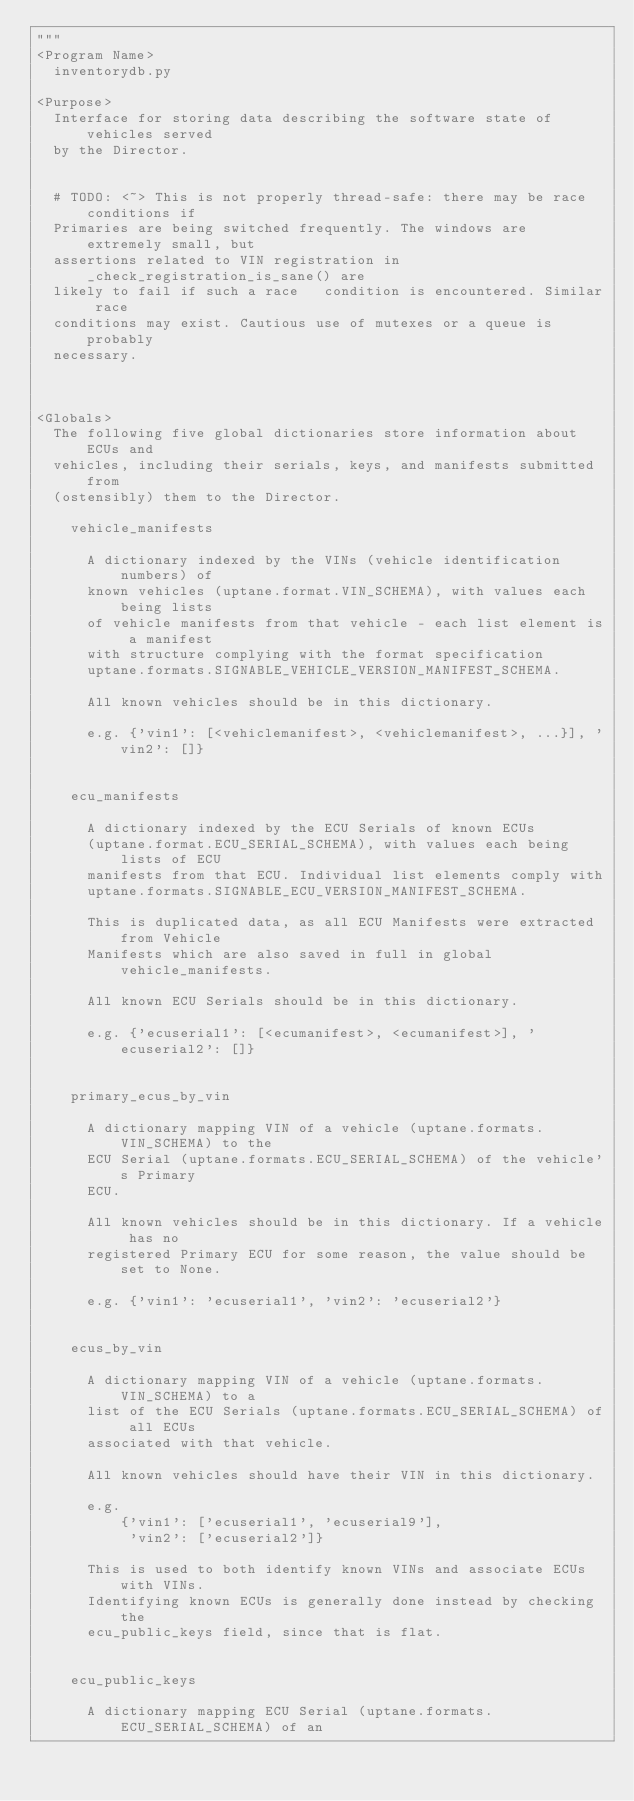Convert code to text. <code><loc_0><loc_0><loc_500><loc_500><_Python_>"""
<Program Name>
  inventorydb.py

<Purpose>
  Interface for storing data describing the software state of vehicles served
  by the Director.


  # TODO: <~> This is not properly thread-safe: there may be race conditions if
  Primaries are being switched frequently. The windows are extremely small, but
  assertions related to VIN registration in _check_registration_is_sane() are
  likely to fail if such a race   condition is encountered. Similar race
  conditions may exist. Cautious use of mutexes or a queue is probably
  necessary.



<Globals>
  The following five global dictionaries store information about ECUs and
  vehicles, including their serials, keys, and manifests submitted from
  (ostensibly) them to the Director.

    vehicle_manifests

      A dictionary indexed by the VINs (vehicle identification numbers) of
      known vehicles (uptane.format.VIN_SCHEMA), with values each being lists
      of vehicle manifests from that vehicle - each list element is a manifest
      with structure complying with the format specification
      uptane.formats.SIGNABLE_VEHICLE_VERSION_MANIFEST_SCHEMA.

      All known vehicles should be in this dictionary.

      e.g. {'vin1': [<vehiclemanifest>, <vehiclemanifest>, ...}], 'vin2': []}


    ecu_manifests

      A dictionary indexed by the ECU Serials of known ECUs
      (uptane.format.ECU_SERIAL_SCHEMA), with values each being lists of ECU
      manifests from that ECU. Individual list elements comply with
      uptane.formats.SIGNABLE_ECU_VERSION_MANIFEST_SCHEMA.

      This is duplicated data, as all ECU Manifests were extracted from Vehicle
      Manifests which are also saved in full in global vehicle_manifests.

      All known ECU Serials should be in this dictionary.

      e.g. {'ecuserial1': [<ecumanifest>, <ecumanifest>], 'ecuserial2': []}


    primary_ecus_by_vin

      A dictionary mapping VIN of a vehicle (uptane.formats.VIN_SCHEMA) to the
      ECU Serial (uptane.formats.ECU_SERIAL_SCHEMA) of the vehicle's Primary
      ECU.

      All known vehicles should be in this dictionary. If a vehicle has no
      registered Primary ECU for some reason, the value should be set to None.

      e.g. {'vin1': 'ecuserial1', 'vin2': 'ecuserial2'}


    ecus_by_vin

      A dictionary mapping VIN of a vehicle (uptane.formats.VIN_SCHEMA) to a
      list of the ECU Serials (uptane.formats.ECU_SERIAL_SCHEMA) of all ECUs
      associated with that vehicle.

      All known vehicles should have their VIN in this dictionary.

      e.g.
          {'vin1': ['ecuserial1', 'ecuserial9'],
           'vin2': ['ecuserial2']}

      This is used to both identify known VINs and associate ECUs with VINs.
      Identifying known ECUs is generally done instead by checking the
      ecu_public_keys field, since that is flat.


    ecu_public_keys

      A dictionary mapping ECU Serial (uptane.formats.ECU_SERIAL_SCHEMA) of an</code> 